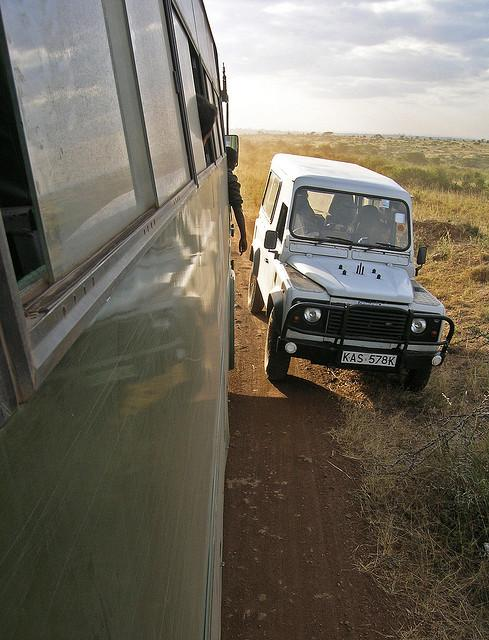In what environment are the Jeep and bus travelling? Please explain your reasoning. savannah. The area is an open savannah. 